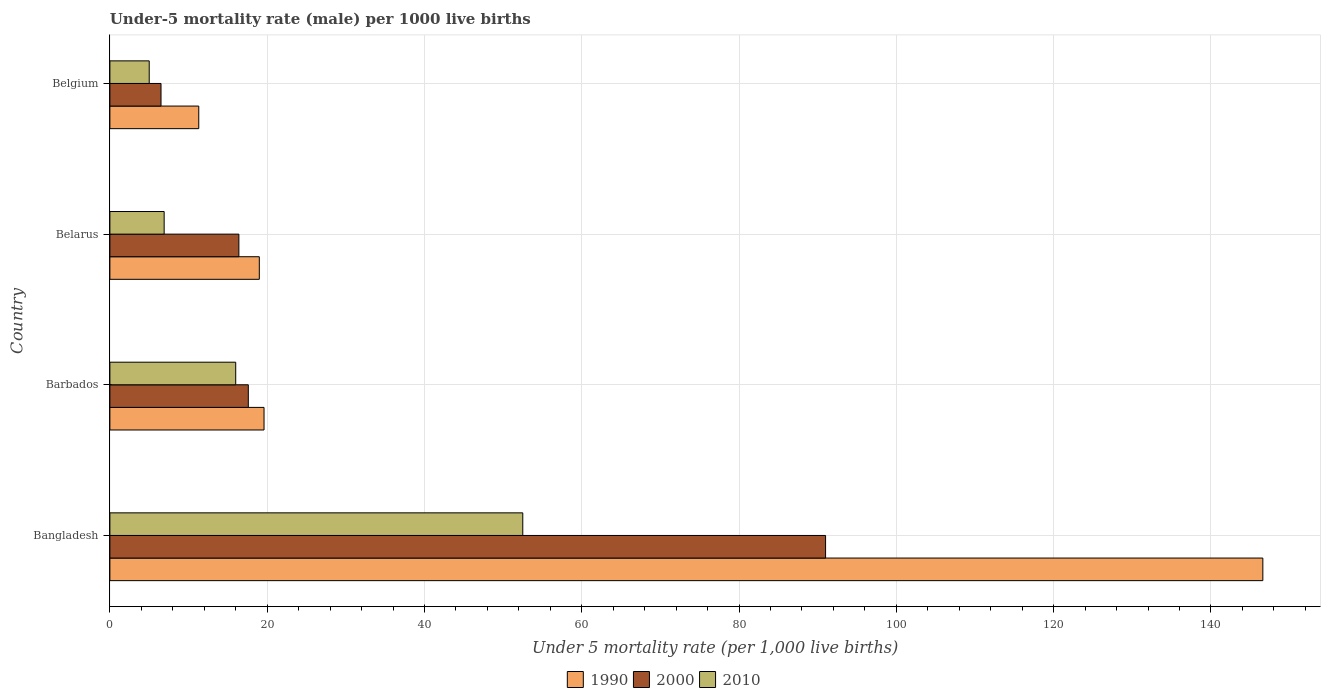How many groups of bars are there?
Give a very brief answer. 4. Are the number of bars on each tick of the Y-axis equal?
Your answer should be very brief. Yes. How many bars are there on the 3rd tick from the top?
Make the answer very short. 3. What is the under-five mortality rate in 2000 in Bangladesh?
Make the answer very short. 91. Across all countries, what is the maximum under-five mortality rate in 1990?
Keep it short and to the point. 146.6. Across all countries, what is the minimum under-five mortality rate in 2000?
Offer a very short reply. 6.5. What is the total under-five mortality rate in 2010 in the graph?
Your answer should be compact. 80.4. What is the difference between the under-five mortality rate in 2000 in Belarus and that in Belgium?
Give a very brief answer. 9.9. What is the average under-five mortality rate in 2010 per country?
Provide a short and direct response. 20.1. What is the difference between the under-five mortality rate in 2000 and under-five mortality rate in 2010 in Belgium?
Your response must be concise. 1.5. What is the difference between the highest and the second highest under-five mortality rate in 1990?
Provide a succinct answer. 127. What is the difference between the highest and the lowest under-five mortality rate in 2010?
Offer a very short reply. 47.5. Is the sum of the under-five mortality rate in 2000 in Barbados and Belgium greater than the maximum under-five mortality rate in 1990 across all countries?
Ensure brevity in your answer.  No. What does the 2nd bar from the bottom in Belgium represents?
Make the answer very short. 2000. Is it the case that in every country, the sum of the under-five mortality rate in 1990 and under-five mortality rate in 2010 is greater than the under-five mortality rate in 2000?
Make the answer very short. Yes. Are all the bars in the graph horizontal?
Keep it short and to the point. Yes. How many countries are there in the graph?
Keep it short and to the point. 4. What is the difference between two consecutive major ticks on the X-axis?
Offer a very short reply. 20. Are the values on the major ticks of X-axis written in scientific E-notation?
Ensure brevity in your answer.  No. Does the graph contain any zero values?
Provide a succinct answer. No. How are the legend labels stacked?
Offer a very short reply. Horizontal. What is the title of the graph?
Provide a succinct answer. Under-5 mortality rate (male) per 1000 live births. What is the label or title of the X-axis?
Your answer should be very brief. Under 5 mortality rate (per 1,0 live births). What is the label or title of the Y-axis?
Provide a succinct answer. Country. What is the Under 5 mortality rate (per 1,000 live births) in 1990 in Bangladesh?
Offer a very short reply. 146.6. What is the Under 5 mortality rate (per 1,000 live births) of 2000 in Bangladesh?
Offer a very short reply. 91. What is the Under 5 mortality rate (per 1,000 live births) in 2010 in Bangladesh?
Provide a short and direct response. 52.5. What is the Under 5 mortality rate (per 1,000 live births) in 1990 in Barbados?
Ensure brevity in your answer.  19.6. What is the Under 5 mortality rate (per 1,000 live births) of 2000 in Barbados?
Offer a terse response. 17.6. What is the Under 5 mortality rate (per 1,000 live births) in 1990 in Belarus?
Your response must be concise. 19. What is the Under 5 mortality rate (per 1,000 live births) of 2000 in Belarus?
Keep it short and to the point. 16.4. What is the Under 5 mortality rate (per 1,000 live births) in 1990 in Belgium?
Keep it short and to the point. 11.3. Across all countries, what is the maximum Under 5 mortality rate (per 1,000 live births) of 1990?
Provide a succinct answer. 146.6. Across all countries, what is the maximum Under 5 mortality rate (per 1,000 live births) of 2000?
Your answer should be very brief. 91. Across all countries, what is the maximum Under 5 mortality rate (per 1,000 live births) in 2010?
Offer a terse response. 52.5. Across all countries, what is the minimum Under 5 mortality rate (per 1,000 live births) in 1990?
Give a very brief answer. 11.3. What is the total Under 5 mortality rate (per 1,000 live births) in 1990 in the graph?
Ensure brevity in your answer.  196.5. What is the total Under 5 mortality rate (per 1,000 live births) of 2000 in the graph?
Your response must be concise. 131.5. What is the total Under 5 mortality rate (per 1,000 live births) in 2010 in the graph?
Provide a short and direct response. 80.4. What is the difference between the Under 5 mortality rate (per 1,000 live births) of 1990 in Bangladesh and that in Barbados?
Keep it short and to the point. 127. What is the difference between the Under 5 mortality rate (per 1,000 live births) of 2000 in Bangladesh and that in Barbados?
Your answer should be very brief. 73.4. What is the difference between the Under 5 mortality rate (per 1,000 live births) of 2010 in Bangladesh and that in Barbados?
Offer a very short reply. 36.5. What is the difference between the Under 5 mortality rate (per 1,000 live births) of 1990 in Bangladesh and that in Belarus?
Provide a succinct answer. 127.6. What is the difference between the Under 5 mortality rate (per 1,000 live births) of 2000 in Bangladesh and that in Belarus?
Give a very brief answer. 74.6. What is the difference between the Under 5 mortality rate (per 1,000 live births) of 2010 in Bangladesh and that in Belarus?
Your answer should be very brief. 45.6. What is the difference between the Under 5 mortality rate (per 1,000 live births) in 1990 in Bangladesh and that in Belgium?
Offer a terse response. 135.3. What is the difference between the Under 5 mortality rate (per 1,000 live births) in 2000 in Bangladesh and that in Belgium?
Give a very brief answer. 84.5. What is the difference between the Under 5 mortality rate (per 1,000 live births) in 2010 in Bangladesh and that in Belgium?
Your answer should be compact. 47.5. What is the difference between the Under 5 mortality rate (per 1,000 live births) in 2010 in Barbados and that in Belarus?
Offer a terse response. 9.1. What is the difference between the Under 5 mortality rate (per 1,000 live births) of 1990 in Barbados and that in Belgium?
Ensure brevity in your answer.  8.3. What is the difference between the Under 5 mortality rate (per 1,000 live births) in 2000 in Barbados and that in Belgium?
Ensure brevity in your answer.  11.1. What is the difference between the Under 5 mortality rate (per 1,000 live births) of 1990 in Belarus and that in Belgium?
Make the answer very short. 7.7. What is the difference between the Under 5 mortality rate (per 1,000 live births) of 2000 in Belarus and that in Belgium?
Your answer should be very brief. 9.9. What is the difference between the Under 5 mortality rate (per 1,000 live births) of 2010 in Belarus and that in Belgium?
Make the answer very short. 1.9. What is the difference between the Under 5 mortality rate (per 1,000 live births) in 1990 in Bangladesh and the Under 5 mortality rate (per 1,000 live births) in 2000 in Barbados?
Your answer should be very brief. 129. What is the difference between the Under 5 mortality rate (per 1,000 live births) of 1990 in Bangladesh and the Under 5 mortality rate (per 1,000 live births) of 2010 in Barbados?
Keep it short and to the point. 130.6. What is the difference between the Under 5 mortality rate (per 1,000 live births) in 1990 in Bangladesh and the Under 5 mortality rate (per 1,000 live births) in 2000 in Belarus?
Your answer should be very brief. 130.2. What is the difference between the Under 5 mortality rate (per 1,000 live births) in 1990 in Bangladesh and the Under 5 mortality rate (per 1,000 live births) in 2010 in Belarus?
Ensure brevity in your answer.  139.7. What is the difference between the Under 5 mortality rate (per 1,000 live births) in 2000 in Bangladesh and the Under 5 mortality rate (per 1,000 live births) in 2010 in Belarus?
Your answer should be compact. 84.1. What is the difference between the Under 5 mortality rate (per 1,000 live births) of 1990 in Bangladesh and the Under 5 mortality rate (per 1,000 live births) of 2000 in Belgium?
Give a very brief answer. 140.1. What is the difference between the Under 5 mortality rate (per 1,000 live births) of 1990 in Bangladesh and the Under 5 mortality rate (per 1,000 live births) of 2010 in Belgium?
Offer a very short reply. 141.6. What is the difference between the Under 5 mortality rate (per 1,000 live births) of 1990 in Barbados and the Under 5 mortality rate (per 1,000 live births) of 2010 in Belarus?
Provide a short and direct response. 12.7. What is the difference between the Under 5 mortality rate (per 1,000 live births) of 1990 in Barbados and the Under 5 mortality rate (per 1,000 live births) of 2010 in Belgium?
Provide a short and direct response. 14.6. What is the difference between the Under 5 mortality rate (per 1,000 live births) in 1990 in Belarus and the Under 5 mortality rate (per 1,000 live births) in 2010 in Belgium?
Give a very brief answer. 14. What is the average Under 5 mortality rate (per 1,000 live births) of 1990 per country?
Make the answer very short. 49.12. What is the average Under 5 mortality rate (per 1,000 live births) of 2000 per country?
Provide a short and direct response. 32.88. What is the average Under 5 mortality rate (per 1,000 live births) in 2010 per country?
Keep it short and to the point. 20.1. What is the difference between the Under 5 mortality rate (per 1,000 live births) of 1990 and Under 5 mortality rate (per 1,000 live births) of 2000 in Bangladesh?
Your answer should be very brief. 55.6. What is the difference between the Under 5 mortality rate (per 1,000 live births) in 1990 and Under 5 mortality rate (per 1,000 live births) in 2010 in Bangladesh?
Offer a very short reply. 94.1. What is the difference between the Under 5 mortality rate (per 1,000 live births) of 2000 and Under 5 mortality rate (per 1,000 live births) of 2010 in Bangladesh?
Offer a very short reply. 38.5. What is the difference between the Under 5 mortality rate (per 1,000 live births) of 1990 and Under 5 mortality rate (per 1,000 live births) of 2000 in Barbados?
Your answer should be compact. 2. What is the difference between the Under 5 mortality rate (per 1,000 live births) in 1990 and Under 5 mortality rate (per 1,000 live births) in 2010 in Barbados?
Your response must be concise. 3.6. What is the difference between the Under 5 mortality rate (per 1,000 live births) in 2000 and Under 5 mortality rate (per 1,000 live births) in 2010 in Barbados?
Ensure brevity in your answer.  1.6. What is the difference between the Under 5 mortality rate (per 1,000 live births) in 1990 and Under 5 mortality rate (per 1,000 live births) in 2000 in Belarus?
Offer a terse response. 2.6. What is the difference between the Under 5 mortality rate (per 1,000 live births) in 1990 and Under 5 mortality rate (per 1,000 live births) in 2000 in Belgium?
Your answer should be compact. 4.8. What is the ratio of the Under 5 mortality rate (per 1,000 live births) of 1990 in Bangladesh to that in Barbados?
Your response must be concise. 7.48. What is the ratio of the Under 5 mortality rate (per 1,000 live births) of 2000 in Bangladesh to that in Barbados?
Your answer should be compact. 5.17. What is the ratio of the Under 5 mortality rate (per 1,000 live births) of 2010 in Bangladesh to that in Barbados?
Offer a very short reply. 3.28. What is the ratio of the Under 5 mortality rate (per 1,000 live births) of 1990 in Bangladesh to that in Belarus?
Your answer should be very brief. 7.72. What is the ratio of the Under 5 mortality rate (per 1,000 live births) of 2000 in Bangladesh to that in Belarus?
Make the answer very short. 5.55. What is the ratio of the Under 5 mortality rate (per 1,000 live births) of 2010 in Bangladesh to that in Belarus?
Keep it short and to the point. 7.61. What is the ratio of the Under 5 mortality rate (per 1,000 live births) in 1990 in Bangladesh to that in Belgium?
Provide a short and direct response. 12.97. What is the ratio of the Under 5 mortality rate (per 1,000 live births) of 2010 in Bangladesh to that in Belgium?
Your answer should be compact. 10.5. What is the ratio of the Under 5 mortality rate (per 1,000 live births) in 1990 in Barbados to that in Belarus?
Your answer should be very brief. 1.03. What is the ratio of the Under 5 mortality rate (per 1,000 live births) of 2000 in Barbados to that in Belarus?
Keep it short and to the point. 1.07. What is the ratio of the Under 5 mortality rate (per 1,000 live births) in 2010 in Barbados to that in Belarus?
Keep it short and to the point. 2.32. What is the ratio of the Under 5 mortality rate (per 1,000 live births) of 1990 in Barbados to that in Belgium?
Give a very brief answer. 1.73. What is the ratio of the Under 5 mortality rate (per 1,000 live births) of 2000 in Barbados to that in Belgium?
Keep it short and to the point. 2.71. What is the ratio of the Under 5 mortality rate (per 1,000 live births) in 2010 in Barbados to that in Belgium?
Your answer should be very brief. 3.2. What is the ratio of the Under 5 mortality rate (per 1,000 live births) in 1990 in Belarus to that in Belgium?
Give a very brief answer. 1.68. What is the ratio of the Under 5 mortality rate (per 1,000 live births) of 2000 in Belarus to that in Belgium?
Provide a short and direct response. 2.52. What is the ratio of the Under 5 mortality rate (per 1,000 live births) in 2010 in Belarus to that in Belgium?
Ensure brevity in your answer.  1.38. What is the difference between the highest and the second highest Under 5 mortality rate (per 1,000 live births) in 1990?
Ensure brevity in your answer.  127. What is the difference between the highest and the second highest Under 5 mortality rate (per 1,000 live births) in 2000?
Keep it short and to the point. 73.4. What is the difference between the highest and the second highest Under 5 mortality rate (per 1,000 live births) in 2010?
Your response must be concise. 36.5. What is the difference between the highest and the lowest Under 5 mortality rate (per 1,000 live births) in 1990?
Offer a very short reply. 135.3. What is the difference between the highest and the lowest Under 5 mortality rate (per 1,000 live births) of 2000?
Ensure brevity in your answer.  84.5. What is the difference between the highest and the lowest Under 5 mortality rate (per 1,000 live births) in 2010?
Give a very brief answer. 47.5. 